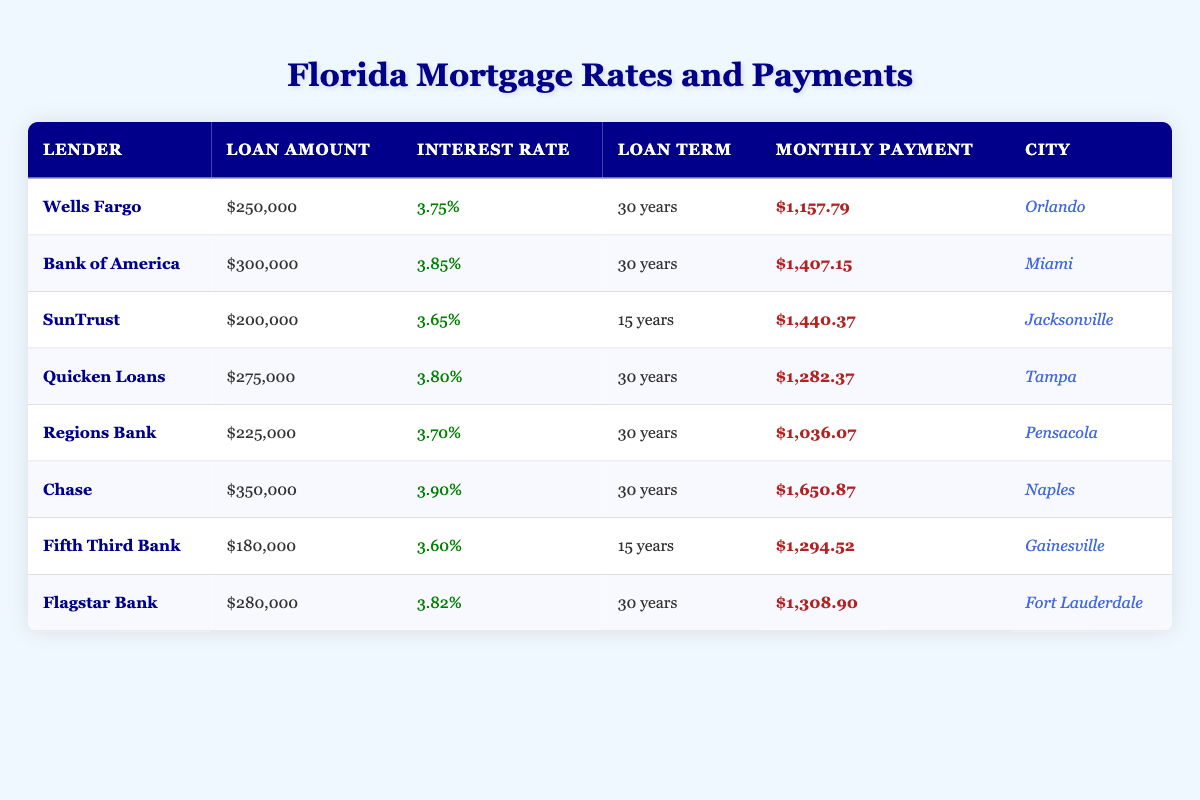What is the highest monthly payment in the table? The highest monthly payment can be found by scanning the "Monthly Payment" column. The respective values are $1,157.79, $1,407.15, $1,440.37, $1,282.37, $1,036.07, $1,650.87, $1,294.52, and $1,308.90. The maximum among these amounts is $1,650.87, which corresponds to Chase in Naples.
Answer: $1,650.87 Which lender offers the lowest interest rate and what is it? To determine the lender with the lowest interest rate, I check the "Interest Rate" column for each lender. The rates are 3.75%, 3.85%, 3.65%, 3.80%, 3.70%, 3.90%, 3.60%, and 3.82%. The lowest rate is 3.60%, which is offered by Fifth Third Bank.
Answer: 3.60% by Fifth Third Bank What is the total loan amount for lenders providing a 30-year term? To find the total loan amount for 30-year terms, I first identify all lenders listed under a 30-year term: Wells Fargo ($250,000), Bank of America ($300,000), Quicken Loans ($275,000), Regions Bank ($225,000), and Chase ($350,000). Adding these amounts gives $250,000 + $300,000 + $275,000 + $225,000 + $350,000 = $1,400,000.
Answer: $1,400,000 Is the monthly payment higher for a 15-year loan compared to a 30-year loan? The monthly payments listed for 15-year loans are: $1,440.37 (SunTrust) and $1,294.52 (Fifth Third Bank). The 30-year loans have monthly payments of: $1,157.79, $1,407.15, $1,282.37, $1,036.07, and $1,650.87. Since the maximum payment for 30 years is $1,650.87, it's clear that the 15-year loan payment of $1,440.37 and $1,294.52 is lower than the maximum for 30 years. Thus, the statement is false.
Answer: No How many lenders have a loan amount of over $250,000? I will count the lenders in the "Loan Amount" column that exceed $250,000. The relevant figures are $250,000, $300,000, $275,000, $280,000, and $350,000. The count is four: Bank of America ($300,000), Quicken Loans ($275,000), Chase ($350,000), and Flagstar Bank ($280,000).
Answer: 4 